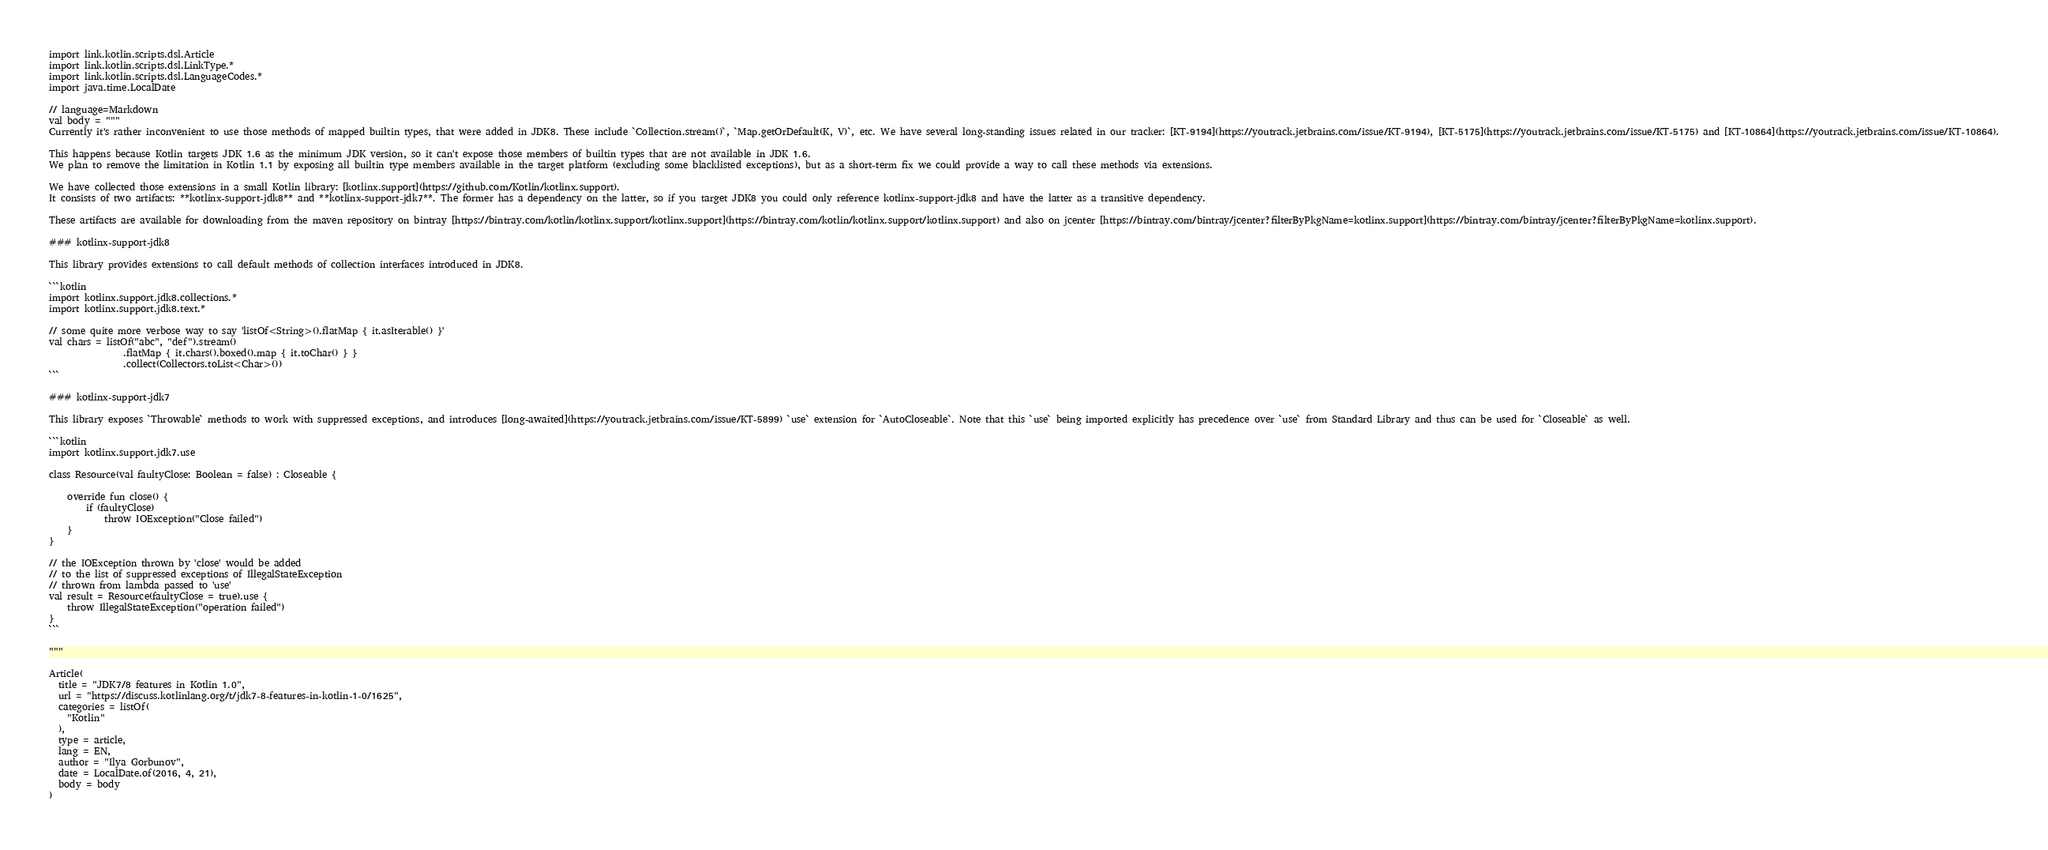Convert code to text. <code><loc_0><loc_0><loc_500><loc_500><_Kotlin_>
import link.kotlin.scripts.dsl.Article
import link.kotlin.scripts.dsl.LinkType.*
import link.kotlin.scripts.dsl.LanguageCodes.*
import java.time.LocalDate

// language=Markdown
val body = """
Currently it's rather inconvenient to use those methods of mapped builtin types, that were added in JDK8. These include `Collection.stream()`, `Map.getOrDefault(K, V)`, etc. We have several long-standing issues related in our tracker: [KT-9194](https://youtrack.jetbrains.com/issue/KT-9194), [KT-5175](https://youtrack.jetbrains.com/issue/KT-5175) and [KT-10864](https://youtrack.jetbrains.com/issue/KT-10864).

This happens because Kotlin targets JDK 1.6 as the minimum JDK version, so it can't expose those members of builtin types that are not available in JDK 1.6.
We plan to remove the limitation in Kotlin 1.1 by exposing all builtin type members available in the target platform (excluding some blacklisted exceptions), but as a short-term fix we could provide a way to call these methods via extensions.

We have collected those extensions in a small Kotlin library: [kotlinx.support](https://github.com/Kotlin/kotlinx.support).
It consists of two artifacts: **kotlinx-support-jdk8** and **kotlinx-support-jdk7**. The former has a dependency on the latter, so if you target JDK8 you could only reference kotlinx-support-jdk8 and have the latter as a transitive dependency.

These artifacts are available for downloading from the maven repository on bintray [https://bintray.com/kotlin/kotlinx.support/kotlinx.support](https://bintray.com/kotlin/kotlinx.support/kotlinx.support) and also on jcenter [https://bintray.com/bintray/jcenter?filterByPkgName=kotlinx.support](https://bintray.com/bintray/jcenter?filterByPkgName=kotlinx.support).

### kotlinx-support-jdk8

This library provides extensions to call default methods of collection interfaces introduced in JDK8.

```kotlin
import kotlinx.support.jdk8.collections.*
import kotlinx.support.jdk8.text.*

// some quite more verbose way to say 'listOf<String>().flatMap { it.asIterable() }'
val chars = listOf("abc", "def").stream()
                .flatMap { it.chars().boxed().map { it.toChar() } }
                .collect(Collectors.toList<Char>())
```

### kotlinx-support-jdk7

This library exposes `Throwable` methods to work with suppressed exceptions, and introduces [long-awaited](https://youtrack.jetbrains.com/issue/KT-5899) `use` extension for `AutoCloseable`. Note that this `use` being imported explicitly has precedence over `use` from Standard Library and thus can be used for `Closeable` as well.

```kotlin
import kotlinx.support.jdk7.use

class Resource(val faultyClose: Boolean = false) : Closeable {

    override fun close() {
        if (faultyClose)
            throw IOException("Close failed")
    }
}

// the IOException thrown by 'close' would be added
// to the list of suppressed exceptions of IllegalStateException
// thrown from lambda passed to 'use'
val result = Resource(faultyClose = true).use {
    throw IllegalStateException("operation failed")
}
```

"""

Article(
  title = "JDK7/8 features in Kotlin 1.0",
  url = "https://discuss.kotlinlang.org/t/jdk7-8-features-in-kotlin-1-0/1625",
  categories = listOf(
    "Kotlin"
  ),
  type = article,
  lang = EN,
  author = "Ilya Gorbunov",
  date = LocalDate.of(2016, 4, 21),
  body = body
)
</code> 